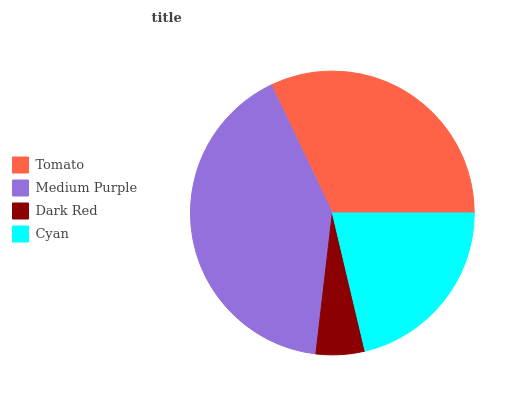Is Dark Red the minimum?
Answer yes or no. Yes. Is Medium Purple the maximum?
Answer yes or no. Yes. Is Medium Purple the minimum?
Answer yes or no. No. Is Dark Red the maximum?
Answer yes or no. No. Is Medium Purple greater than Dark Red?
Answer yes or no. Yes. Is Dark Red less than Medium Purple?
Answer yes or no. Yes. Is Dark Red greater than Medium Purple?
Answer yes or no. No. Is Medium Purple less than Dark Red?
Answer yes or no. No. Is Tomato the high median?
Answer yes or no. Yes. Is Cyan the low median?
Answer yes or no. Yes. Is Medium Purple the high median?
Answer yes or no. No. Is Dark Red the low median?
Answer yes or no. No. 